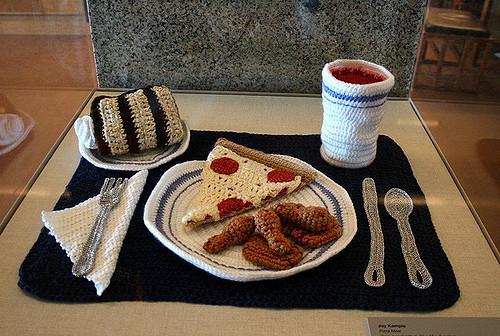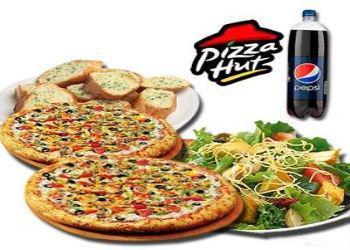The first image is the image on the left, the second image is the image on the right. For the images shown, is this caption "In the image on the right, the pizza is placed next to a salad." true? Answer yes or no. Yes. The first image is the image on the left, the second image is the image on the right. Examine the images to the left and right. Is the description "At least one of the drinks is in a paper cup." accurate? Answer yes or no. No. 